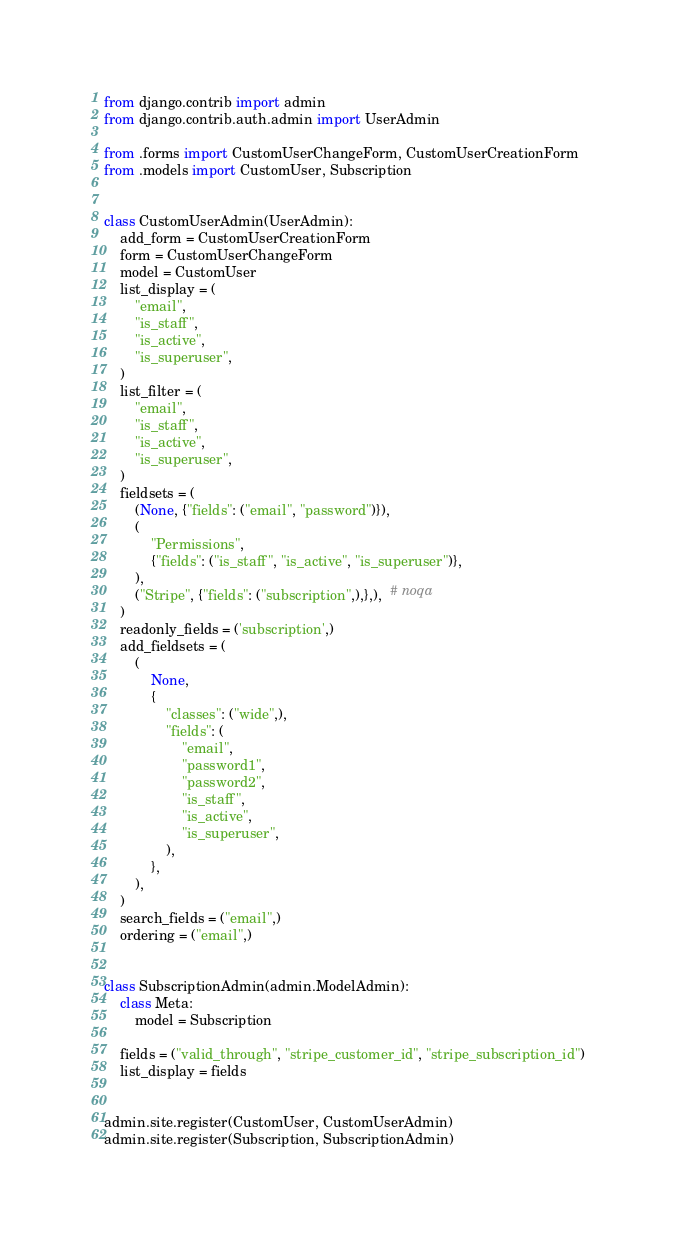Convert code to text. <code><loc_0><loc_0><loc_500><loc_500><_Python_>from django.contrib import admin
from django.contrib.auth.admin import UserAdmin

from .forms import CustomUserChangeForm, CustomUserCreationForm
from .models import CustomUser, Subscription


class CustomUserAdmin(UserAdmin):
    add_form = CustomUserCreationForm
    form = CustomUserChangeForm
    model = CustomUser
    list_display = (
        "email",
        "is_staff",
        "is_active",
        "is_superuser",
    )
    list_filter = (
        "email",
        "is_staff",
        "is_active",
        "is_superuser",
    )
    fieldsets = (
        (None, {"fields": ("email", "password")}),
        (
            "Permissions",
            {"fields": ("is_staff", "is_active", "is_superuser")},
        ),
        ("Stripe", {"fields": ("subscription",),},),  # noqa
    )
    readonly_fields = ('subscription',)
    add_fieldsets = (
        (
            None,
            {
                "classes": ("wide",),
                "fields": (
                    "email",
                    "password1",
                    "password2",
                    "is_staff",
                    "is_active",
                    "is_superuser",
                ),
            },
        ),
    )
    search_fields = ("email",)
    ordering = ("email",)


class SubscriptionAdmin(admin.ModelAdmin):
    class Meta:
        model = Subscription

    fields = ("valid_through", "stripe_customer_id", "stripe_subscription_id")
    list_display = fields


admin.site.register(CustomUser, CustomUserAdmin)
admin.site.register(Subscription, SubscriptionAdmin)
</code> 